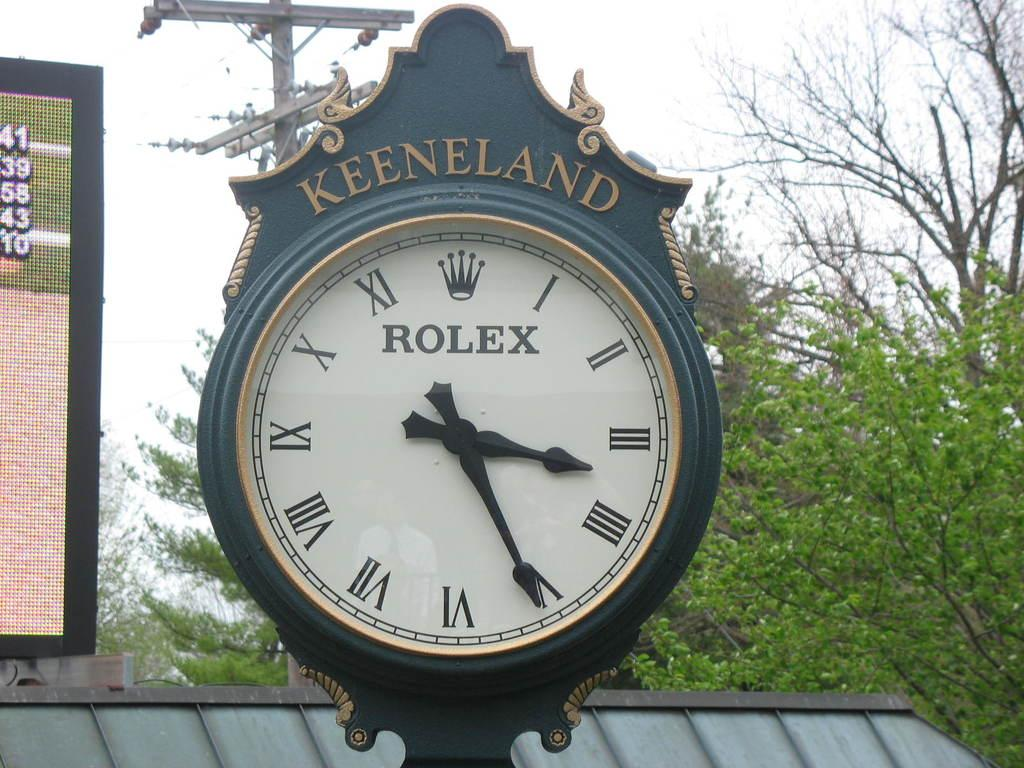Provide a one-sentence caption for the provided image. A Keeneland Rolex clock shows the time of 3:26. 